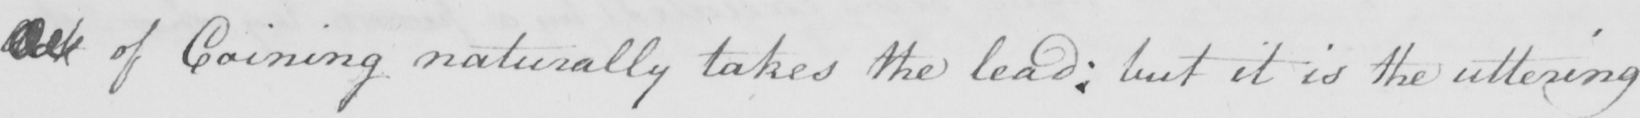What does this handwritten line say? Act of Coining naturally takes the lead :  but it is the uttering 